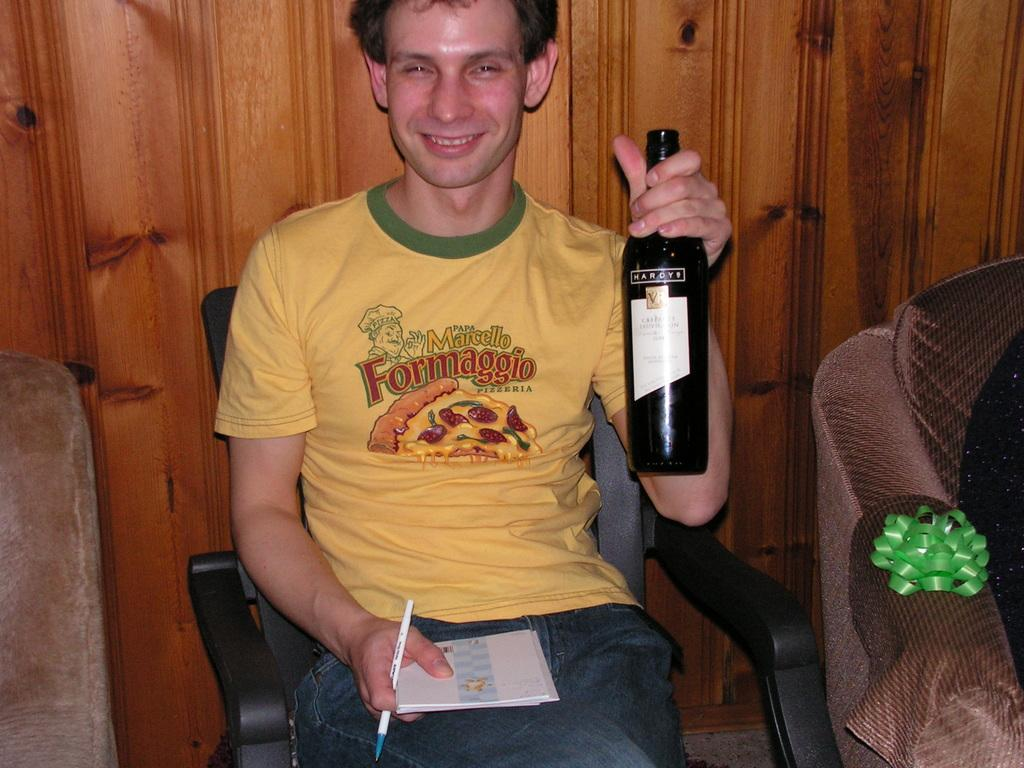What is the man in the image doing? The man is sitting on a chair in the image. What objects is the man holding? The man is holding a black color bottle, a book, and a pen. What furniture is visible on the right side of the image? There is a sofa on the right side of the image. How much does the dime on the man's lap weigh in the image? There is no dime visible on the man's lap in the image. 